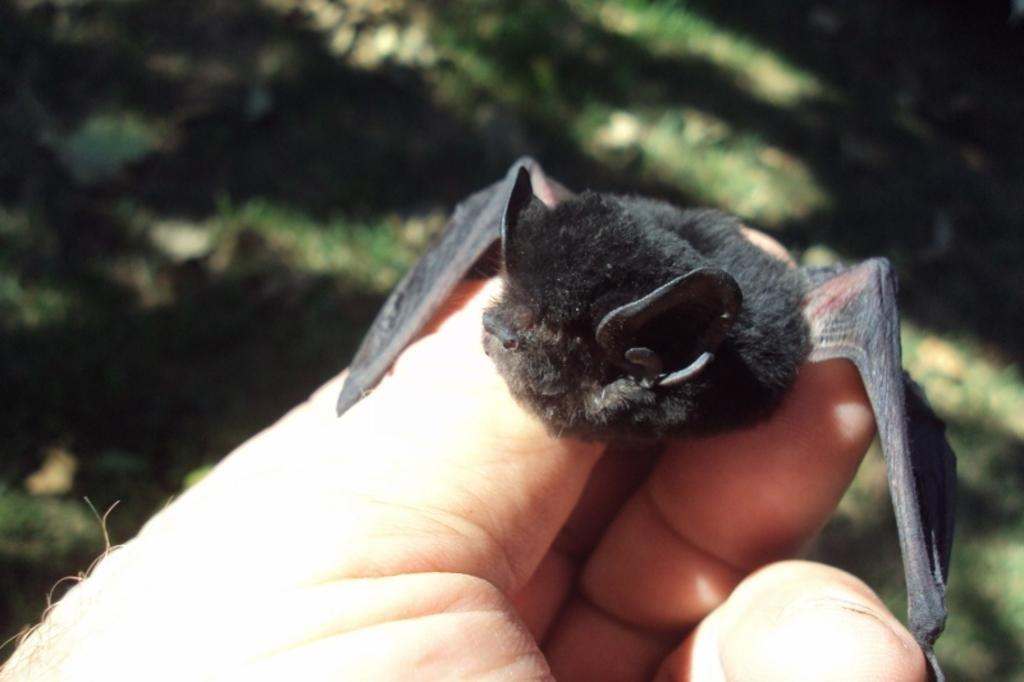What is the person holding in the image? There is a hand holding a bat in the image. Can you describe the background of the image? The background of the image is blurred. What type of food is the person eating in the image? There is no food present in the image; it only shows a hand holding a bat. Who is the owner of the bat in the image? The image does not provide information about the ownership of the bat, so it cannot be determined. Is the person's sister visible in the image? There is no indication of the person's sister or any other person in the image; it only shows a hand holding a bat. 